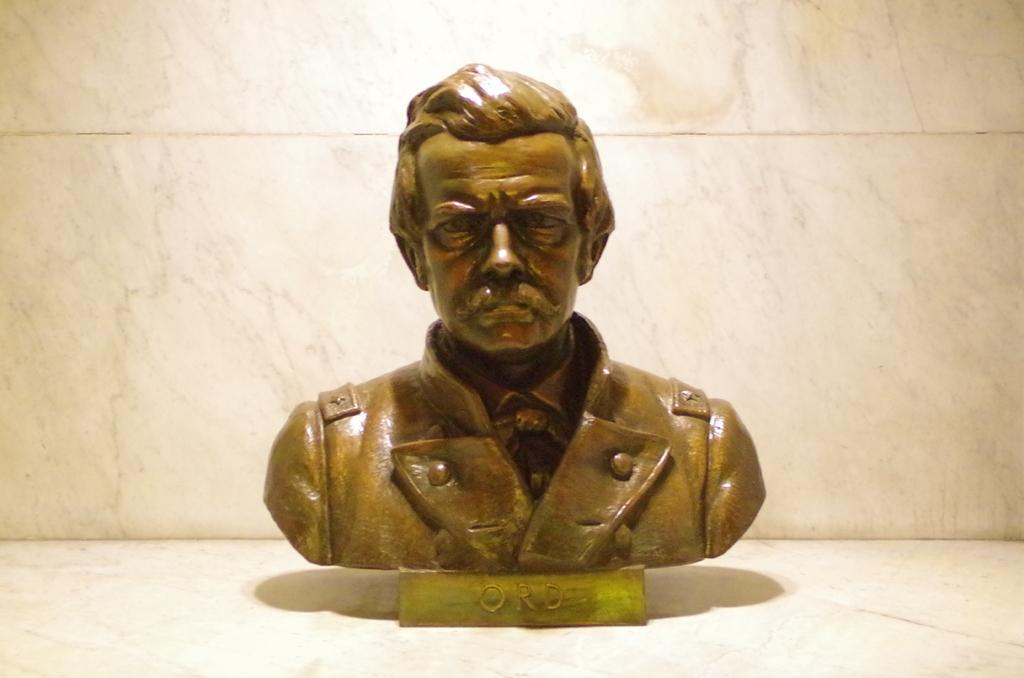What is the main subject in the image? There is a person statue in the image. What color is the person statue? The person statue is in brown color. What color is the background of the image? The background of the image is white. What type of company is depicted in the image? There is no company depicted in the image; it features a person statue. What is the mist like in the image? There is no mist present in the image. 